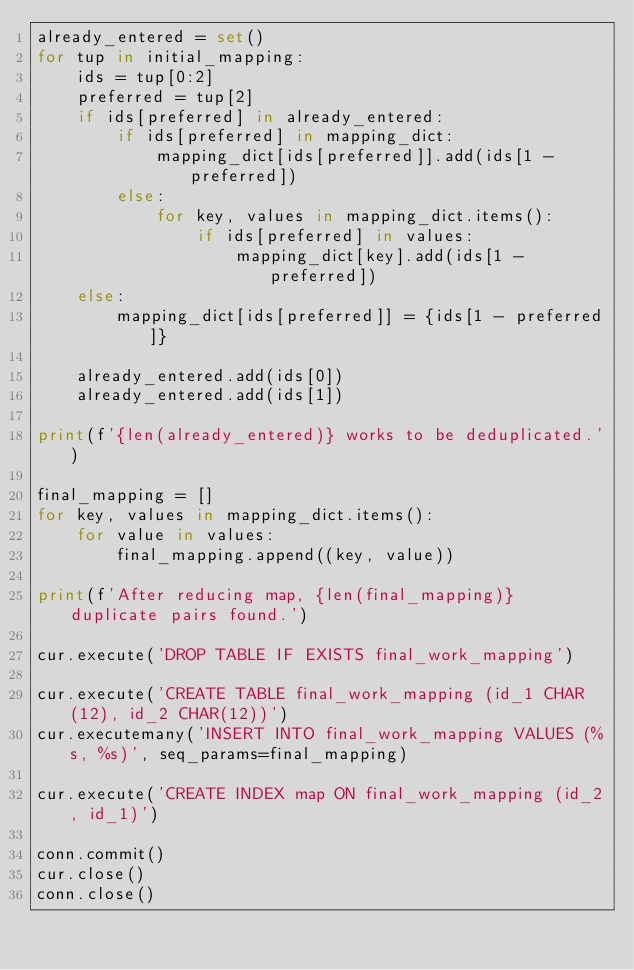<code> <loc_0><loc_0><loc_500><loc_500><_Python_>already_entered = set()
for tup in initial_mapping:
    ids = tup[0:2]
    preferred = tup[2]
    if ids[preferred] in already_entered:
        if ids[preferred] in mapping_dict:
            mapping_dict[ids[preferred]].add(ids[1 - preferred])
        else:
            for key, values in mapping_dict.items():
                if ids[preferred] in values:
                    mapping_dict[key].add(ids[1 - preferred])
    else:
        mapping_dict[ids[preferred]] = {ids[1 - preferred]}
        
    already_entered.add(ids[0])
    already_entered.add(ids[1])

print(f'{len(already_entered)} works to be deduplicated.')

final_mapping = []
for key, values in mapping_dict.items():
    for value in values:
        final_mapping.append((key, value))

print(f'After reducing map, {len(final_mapping)} duplicate pairs found.')

cur.execute('DROP TABLE IF EXISTS final_work_mapping')

cur.execute('CREATE TABLE final_work_mapping (id_1 CHAR(12), id_2 CHAR(12))')
cur.executemany('INSERT INTO final_work_mapping VALUES (%s, %s)', seq_params=final_mapping)

cur.execute('CREATE INDEX map ON final_work_mapping (id_2, id_1)')

conn.commit()
cur.close()
conn.close()
</code> 